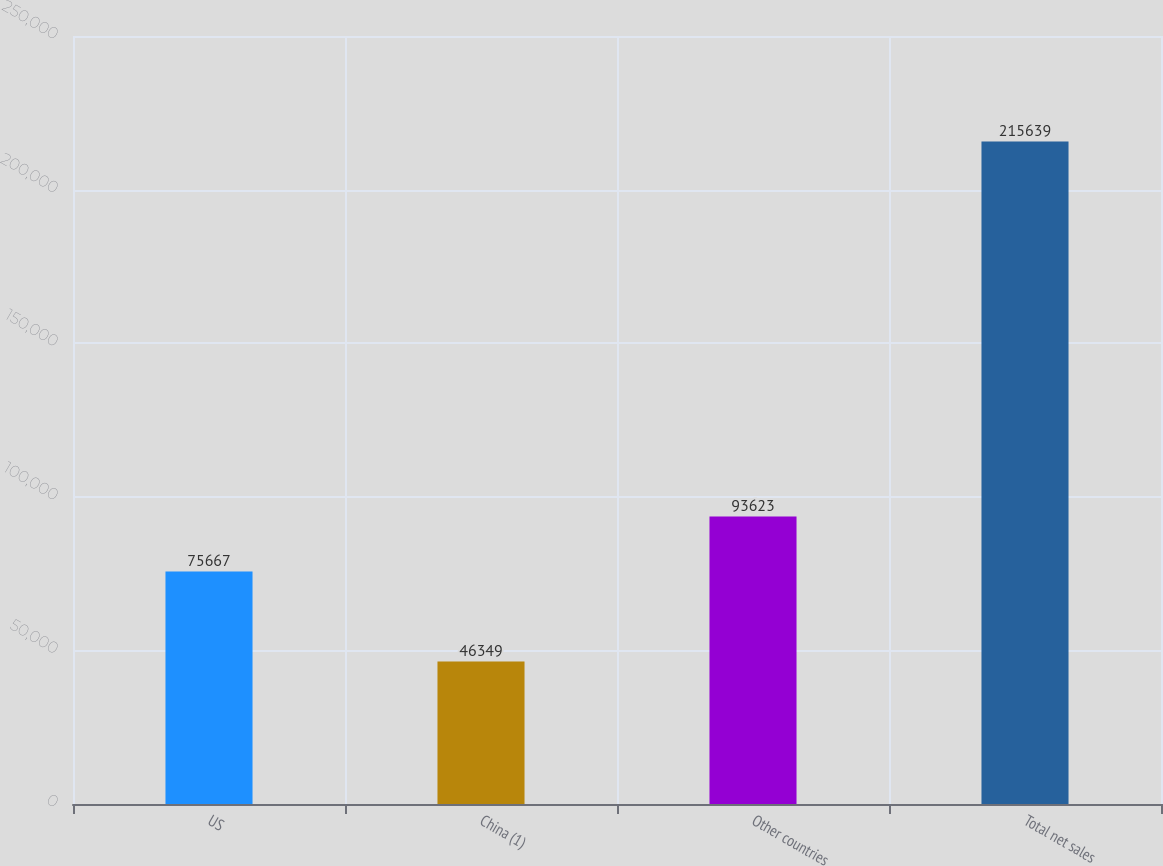Convert chart to OTSL. <chart><loc_0><loc_0><loc_500><loc_500><bar_chart><fcel>US<fcel>China (1)<fcel>Other countries<fcel>Total net sales<nl><fcel>75667<fcel>46349<fcel>93623<fcel>215639<nl></chart> 